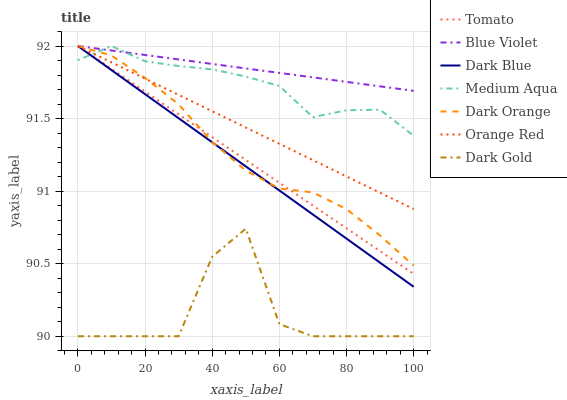Does Dark Gold have the minimum area under the curve?
Answer yes or no. Yes. Does Blue Violet have the maximum area under the curve?
Answer yes or no. Yes. Does Dark Orange have the minimum area under the curve?
Answer yes or no. No. Does Dark Orange have the maximum area under the curve?
Answer yes or no. No. Is Tomato the smoothest?
Answer yes or no. Yes. Is Dark Gold the roughest?
Answer yes or no. Yes. Is Dark Orange the smoothest?
Answer yes or no. No. Is Dark Orange the roughest?
Answer yes or no. No. Does Dark Gold have the lowest value?
Answer yes or no. Yes. Does Dark Orange have the lowest value?
Answer yes or no. No. Does Blue Violet have the highest value?
Answer yes or no. Yes. Does Dark Gold have the highest value?
Answer yes or no. No. Is Dark Gold less than Orange Red?
Answer yes or no. Yes. Is Medium Aqua greater than Dark Gold?
Answer yes or no. Yes. Does Tomato intersect Dark Orange?
Answer yes or no. Yes. Is Tomato less than Dark Orange?
Answer yes or no. No. Is Tomato greater than Dark Orange?
Answer yes or no. No. Does Dark Gold intersect Orange Red?
Answer yes or no. No. 